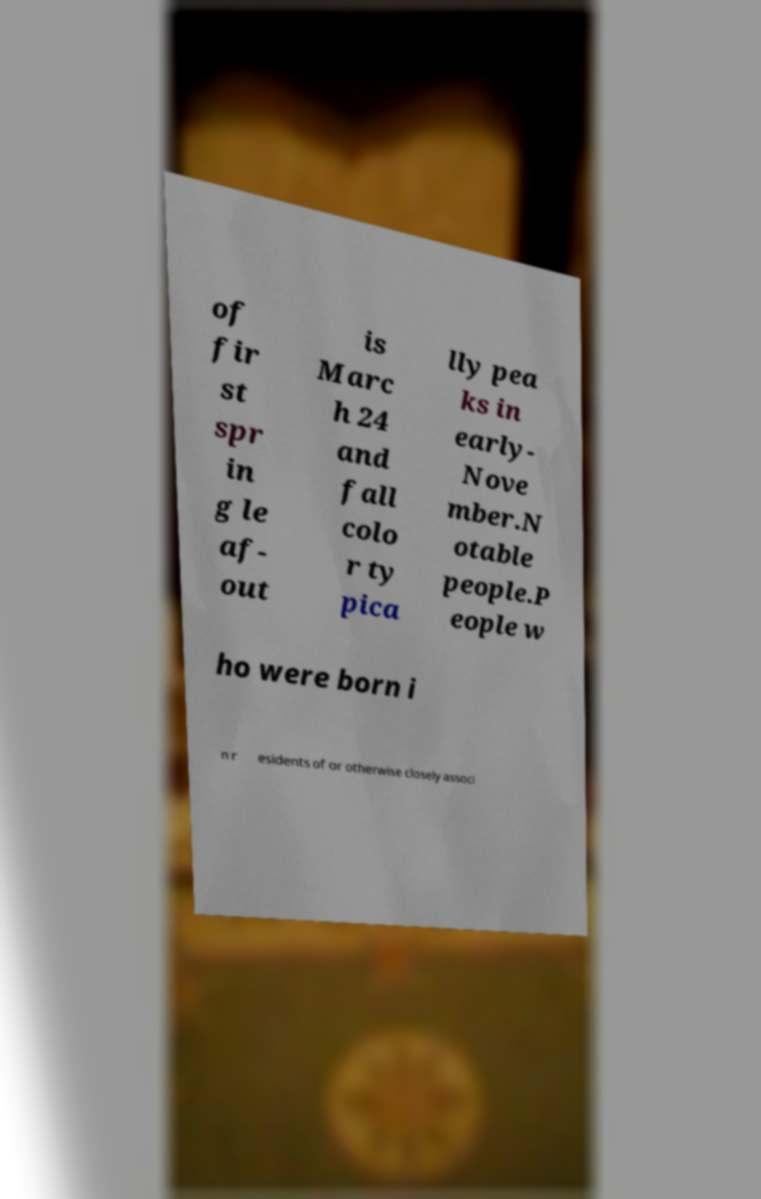Could you extract and type out the text from this image? of fir st spr in g le af- out is Marc h 24 and fall colo r ty pica lly pea ks in early- Nove mber.N otable people.P eople w ho were born i n r esidents of or otherwise closely associ 